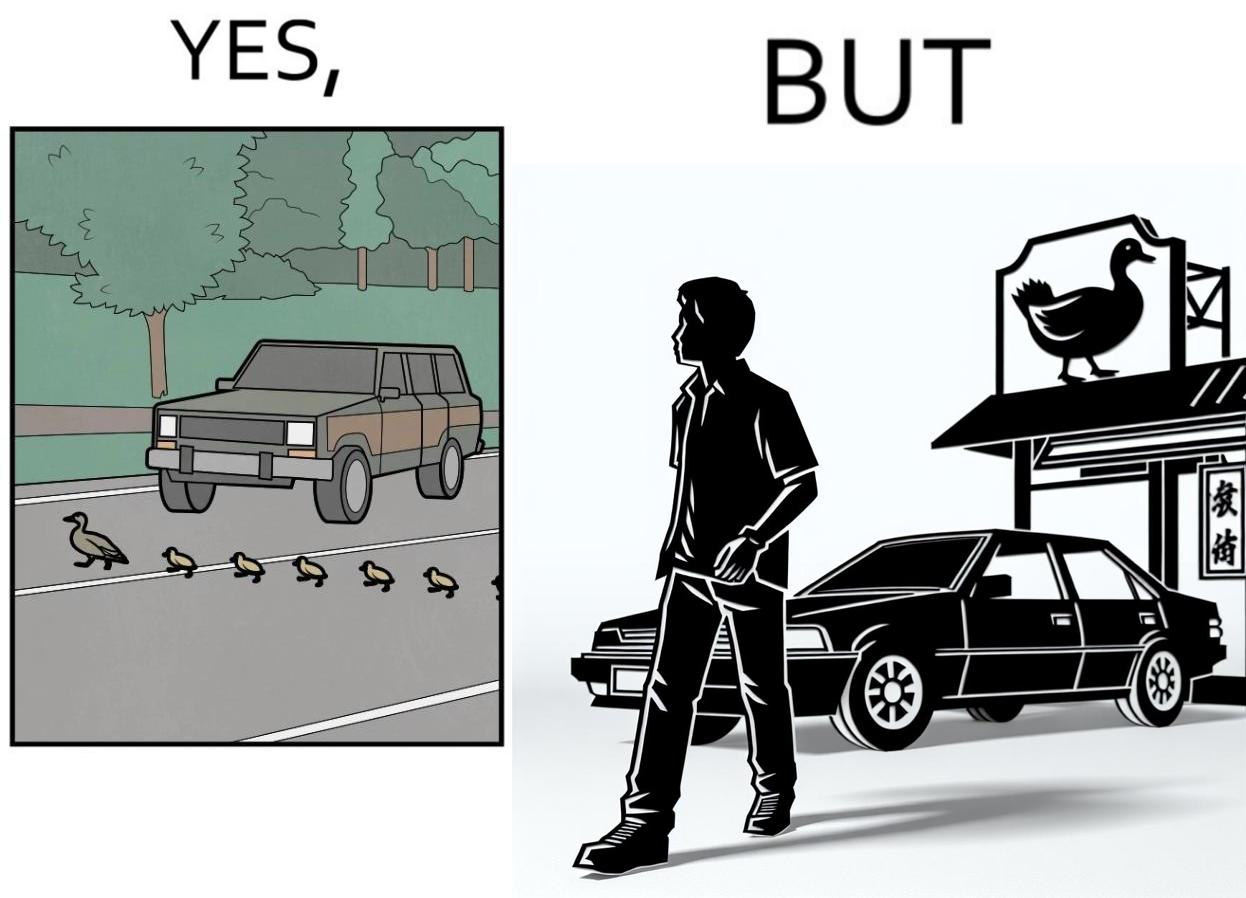Why is this image considered satirical? The images are ironic since they show how a man supposedly cares for ducks since he stops his vehicle to give way to queue of ducks allowing them to safely cross a road but on the other hand he goes to a peking duck shop to buy and eat similar ducks after having them killed 